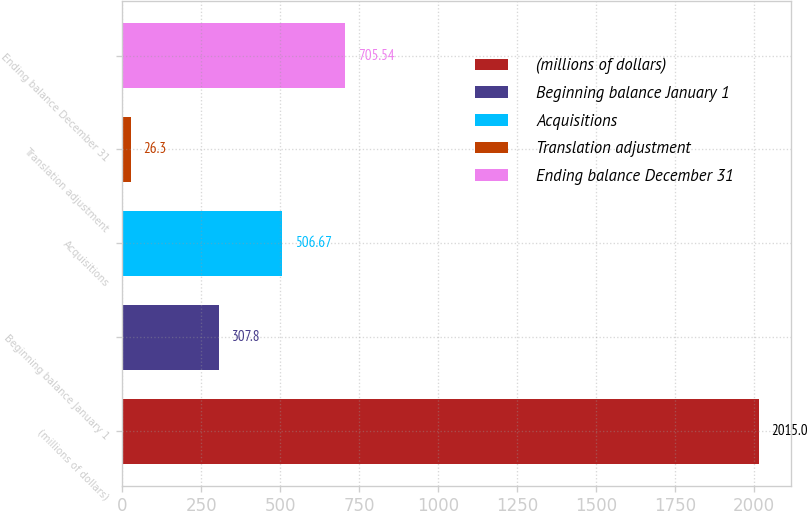Convert chart. <chart><loc_0><loc_0><loc_500><loc_500><bar_chart><fcel>(millions of dollars)<fcel>Beginning balance January 1<fcel>Acquisitions<fcel>Translation adjustment<fcel>Ending balance December 31<nl><fcel>2015<fcel>307.8<fcel>506.67<fcel>26.3<fcel>705.54<nl></chart> 